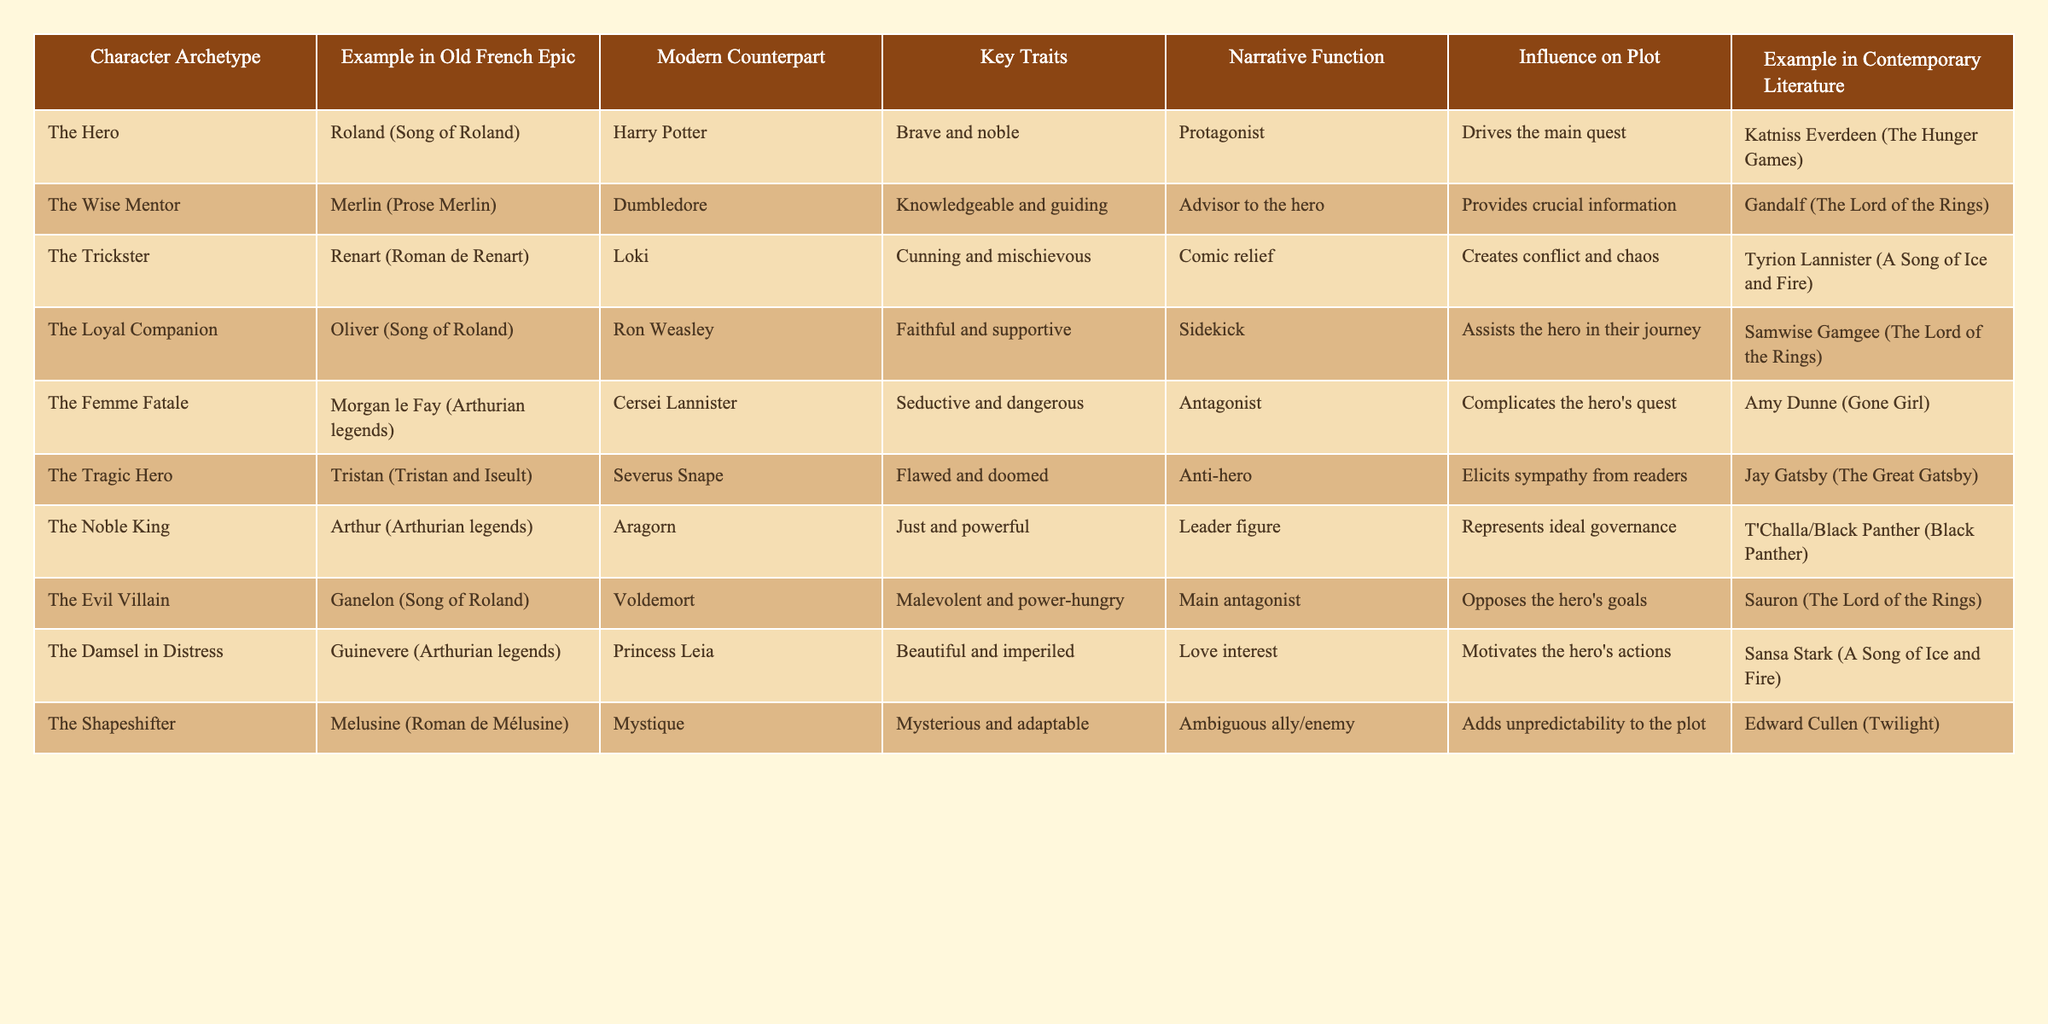What character archetype is represented by Roland in Old French epics? The table lists Roland as an example of "The Hero" archetype in Old French epics.
Answer: The Hero Which modern counterpart corresponds to Merlin from the Prose Merlin? According to the table, the modern counterpart for Merlin is Dumbledore.
Answer: Dumbledore Is the character Oliver in Old French literature portrayed as a loyal companion? The table specifically categorizes Oliver as "The Loyal Companion."
Answer: Yes What are the key traits of the Femme Fatale archetype as seen in Morgan le Fay? The table describes Morgan le Fay as seductive and dangerous, which are key traits of the Femme Fatale.
Answer: Seductive and dangerous How many character archetypes are listed in the table? Counting the entries in the table reveals there are a total of 10 character archetypes listed.
Answer: 10 Which character archetypes share similar traits between the Old French epics and modern literature? Comparing the table entries, archetypes like The Hero (Roland and Harry Potter) and The Wise Mentor (Merlin and Dumbledore) share similar traits.
Answer: The Hero and The Wise Mentor Which modern character serves as an antagonist similar to Ganelon from the Song of Roland? The table indicates that Voldemort serves as the modern counterpart to Ganelon, both fulfilling the antagonist role.
Answer: Voldemort Who are the protagonists in both Old French literature and the examples from contemporary literature? The table highlights heroes such as Roland and Harry Potter as well as Katniss Everdeen, all acting as protagonists in their respective narratives.
Answer: Roland, Harry Potter, Katniss Everdeen What narrative function does the Trickster archetype serve according to the table? The table states that the Trickster archetype, exemplified by Renart, creates conflict and chaos, serving a crucial narrative function.
Answer: Creates conflict and chaos Which archetype is most closely associated with tragedy and flawed characters? The table names Tristan from Tristan and Iseult as a Tragic Hero, illustrating the archetype linked to tragedy and flaws.
Answer: The Tragic Hero In modern literature, which character is a counterpart to Melusine from the Roman de Mélusine? The table identifies Mystique as the modern counterpart to Melusine.
Answer: Mystique 